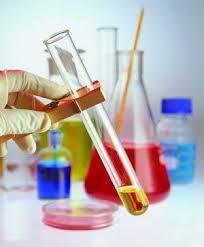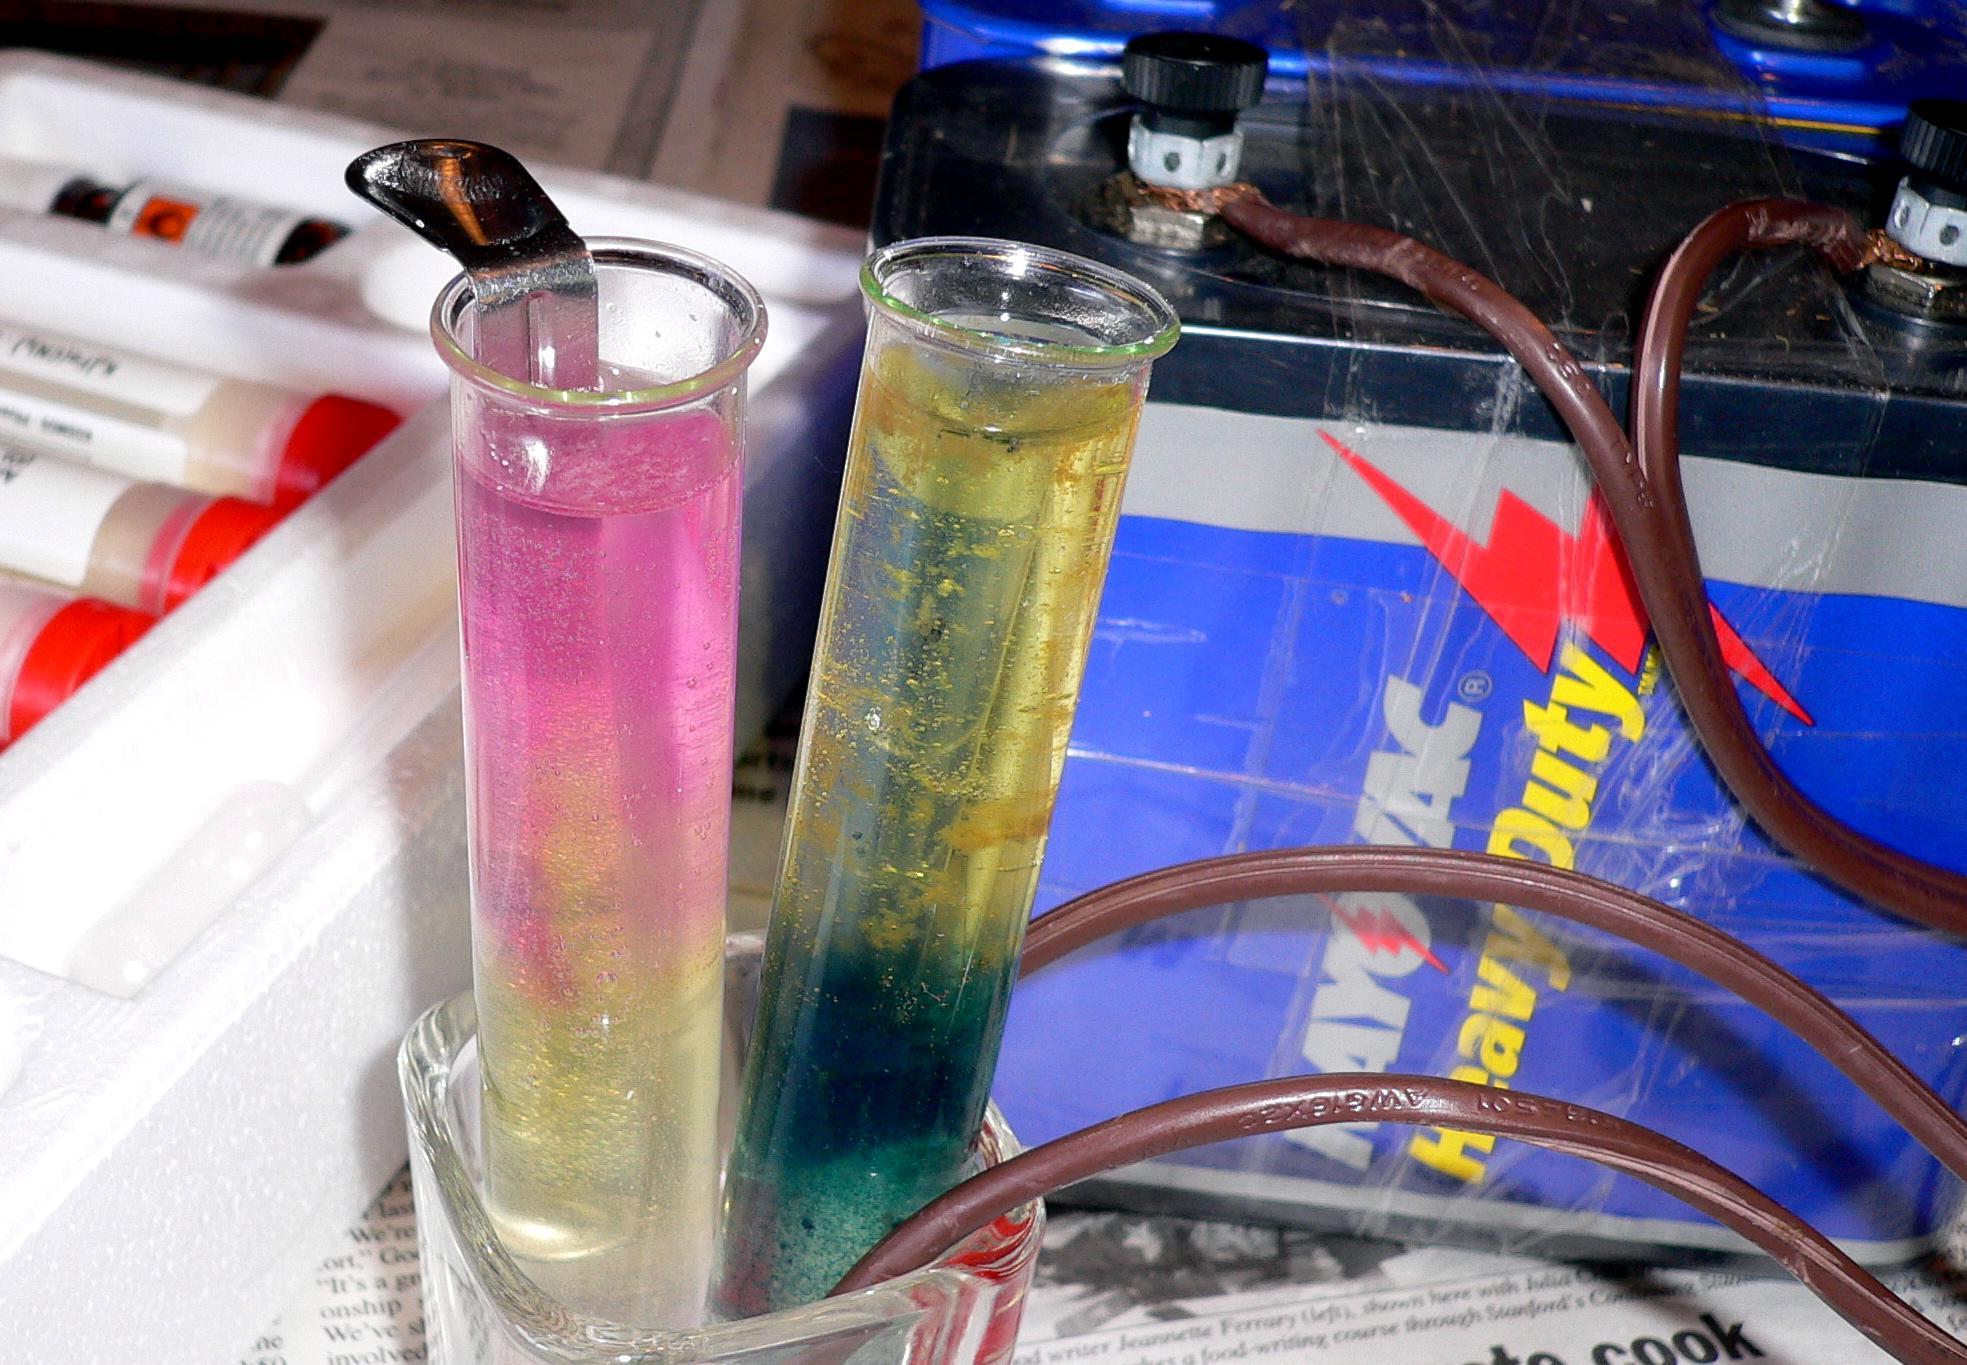The first image is the image on the left, the second image is the image on the right. For the images displayed, is the sentence "One image features exactly five beakers of different liquid colors, in the same shape but different sizes." factually correct? Answer yes or no. No. The first image is the image on the left, the second image is the image on the right. For the images shown, is this caption "There are at least 11 beakers with there pourer facing left." true? Answer yes or no. No. 